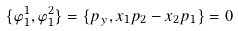Convert formula to latex. <formula><loc_0><loc_0><loc_500><loc_500>\{ \varphi _ { 1 } ^ { 1 } , \varphi _ { 1 } ^ { 2 } \} = \{ p _ { y } , x _ { 1 } p _ { 2 } - x _ { 2 } p _ { 1 } \} = 0</formula> 